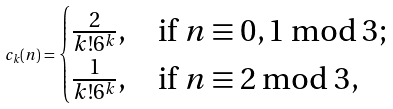Convert formula to latex. <formula><loc_0><loc_0><loc_500><loc_500>c _ { k } ( n ) = \begin{cases} \frac { 2 } { k ! 6 ^ { k } } , & \text {if $n \equiv 0, 1 \bmod 3$;} \\ \frac { 1 } { k ! 6 ^ { k } } , & \text {if $n \equiv 2 \bmod 3$,} \end{cases}</formula> 